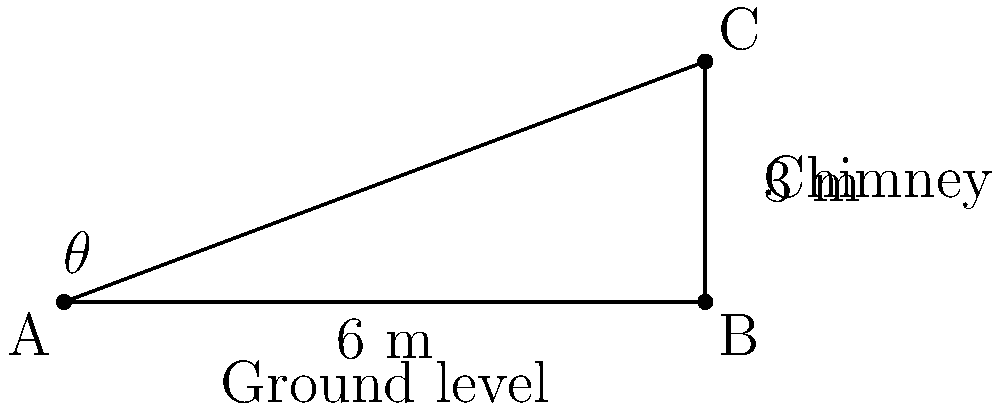A traditional Maltese bread oven's chimney needs to be installed. The base of the chimney is 6 meters away from the oven, and the top of the chimney needs to be 3 meters high. What is the angle of inclination ($\theta$) for the chimney with respect to the ground? To find the angle of inclination, we can use the trigonometric function tangent. Let's approach this step-by-step:

1) In the right triangle ABC:
   - The adjacent side (AB) is 6 meters (horizontal distance)
   - The opposite side (BC) is 3 meters (vertical height)
   - We need to find the angle $\theta$ at A

2) The tangent of an angle is defined as the ratio of the opposite side to the adjacent side:

   $\tan(\theta) = \frac{\text{opposite}}{\text{adjacent}} = \frac{BC}{AB}$

3) Substituting the values:

   $\tan(\theta) = \frac{3}{6} = \frac{1}{2} = 0.5$

4) To find $\theta$, we need to use the inverse tangent (arctan or $\tan^{-1}$):

   $\theta = \tan^{-1}(0.5)$

5) Using a calculator or trigonometric tables:

   $\theta \approx 26.57°$

Therefore, the angle of inclination for the chimney should be approximately 26.57 degrees from the ground.
Answer: $26.57°$ 